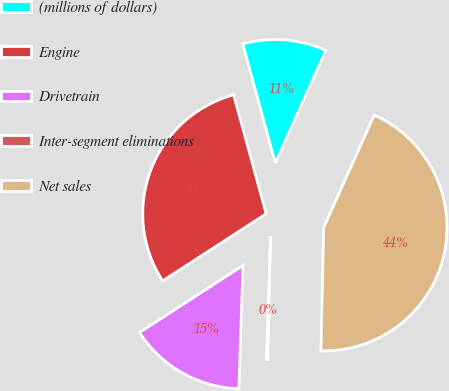<chart> <loc_0><loc_0><loc_500><loc_500><pie_chart><fcel>(millions of dollars)<fcel>Engine<fcel>Drivetrain<fcel>Inter-segment eliminations<fcel>Net sales<nl><fcel>10.96%<fcel>29.91%<fcel>15.31%<fcel>0.18%<fcel>43.64%<nl></chart> 